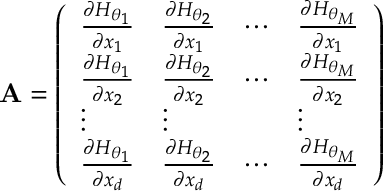Convert formula to latex. <formula><loc_0><loc_0><loc_500><loc_500>A = \left ( \begin{array} { l l l l } { \frac { \partial H _ { \boldsymbol \theta _ { 1 } } } { \partial x _ { 1 } } } & { \frac { \partial H _ { \boldsymbol \theta _ { 2 } } } { \partial x _ { 1 } } } & { \cdots } & { \frac { \partial H _ { \boldsymbol \theta _ { M } } } { \partial x _ { 1 } } } \\ { \frac { \partial H _ { \boldsymbol \theta _ { 1 } } } { \partial x _ { 2 } } } & { \frac { \partial H _ { \boldsymbol \theta _ { 2 } } } { \partial x _ { 2 } } } & { \cdots } & { \frac { \partial H _ { \boldsymbol \theta _ { M } } } { \partial x _ { 2 } } } \\ { \vdots } & { \vdots } & & { \vdots } \\ { \frac { \partial H _ { \boldsymbol \theta _ { 1 } } } { \partial x _ { d } } } & { \frac { \partial H _ { \boldsymbol \theta _ { 2 } } } { \partial x _ { d } } } & { \cdots } & { \frac { \partial H _ { \boldsymbol \theta _ { M } } } { \partial x _ { d } } } \end{array} \right )</formula> 